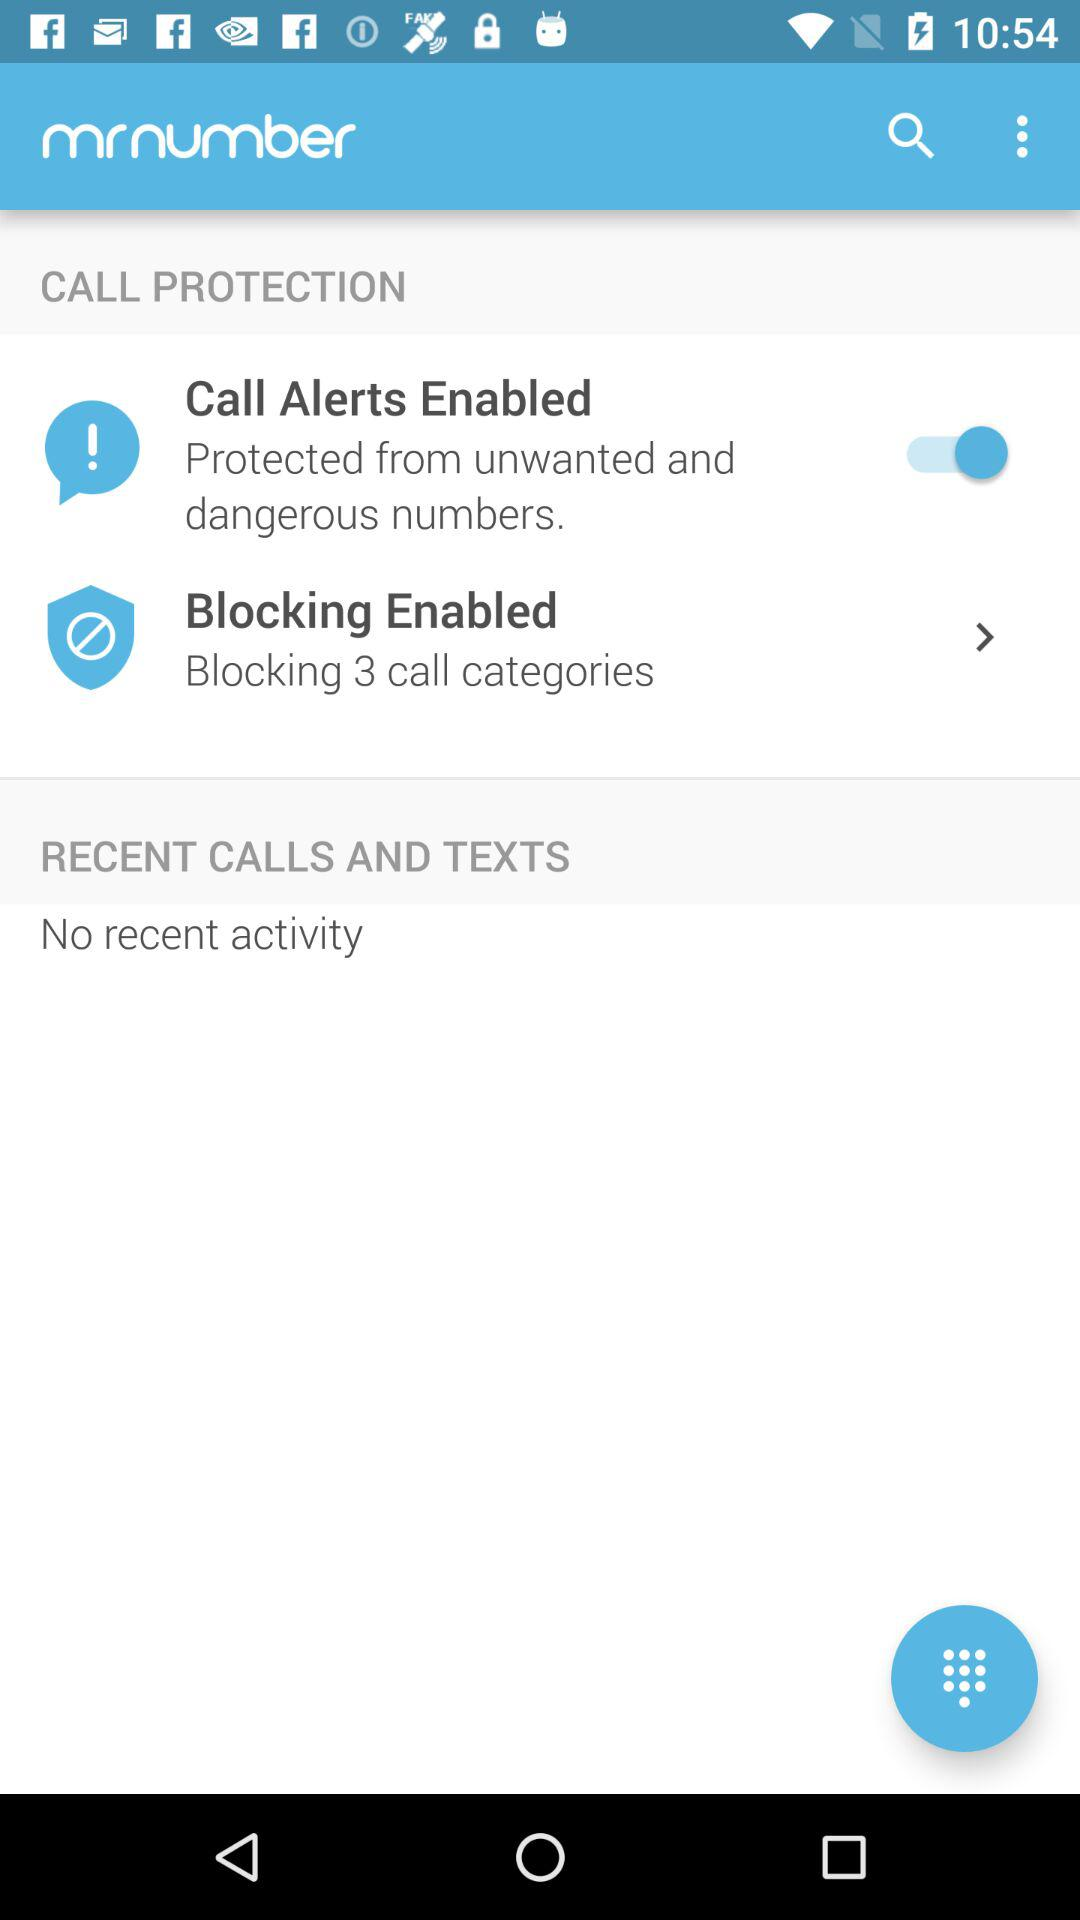How many call categories are being blocked?
Answer the question using a single word or phrase. 3 